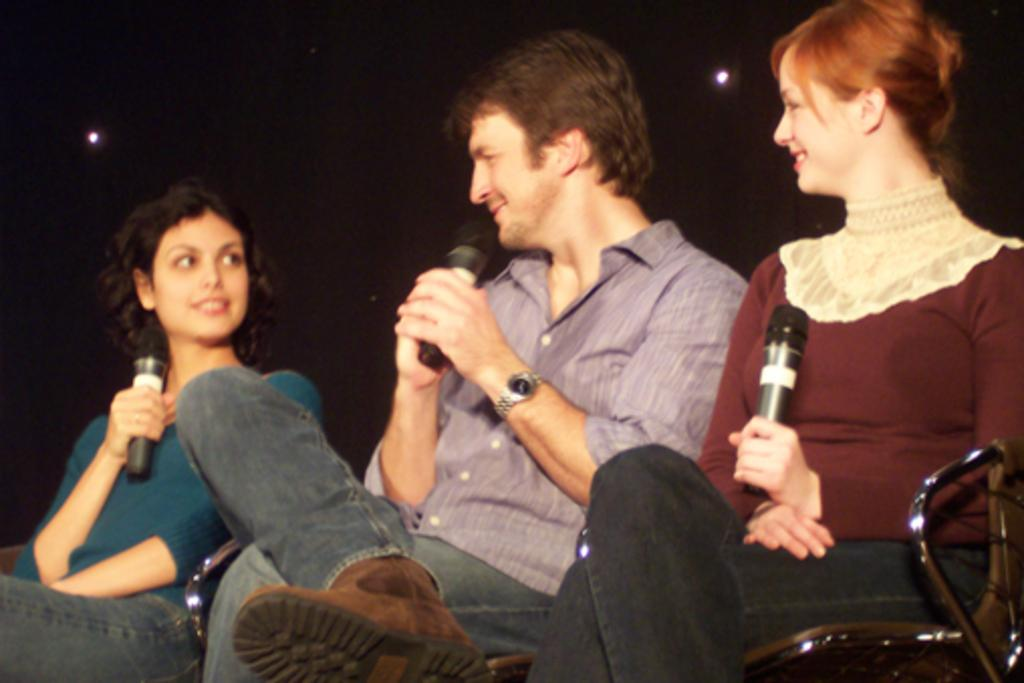How many people are in the image? There are three people in the image: one man and two women. What are the people in the image doing? The man and women are sitting on chairs and holding microphones. What can be seen in the background of the image? There are lights visible in the background of the image. What type of field can be seen in the background of the image? There is no field visible in the background of the image; only lights are present. How many crates are being carried by the women in the image? There are no crates present in the image; the women are holding microphones. 